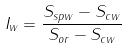<formula> <loc_0><loc_0><loc_500><loc_500>I _ { w } = \frac { S _ { s p w } - S _ { c w } } { S _ { o r } - S _ { c w } }</formula> 